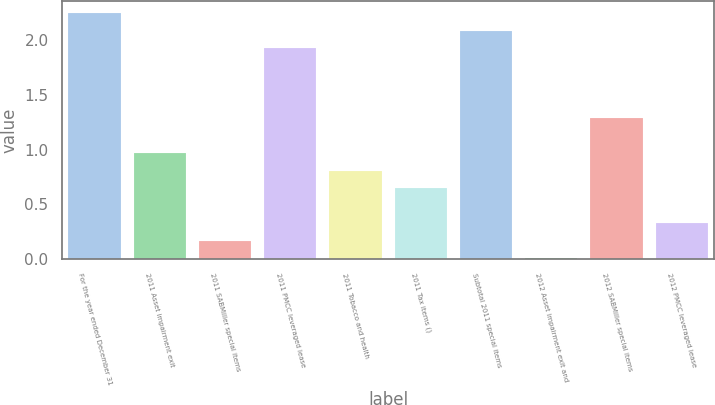<chart> <loc_0><loc_0><loc_500><loc_500><bar_chart><fcel>For the year ended December 31<fcel>2011 Asset impairment exit<fcel>2011 SABMiller special items<fcel>2011 PMCC leveraged lease<fcel>2011 Tobacco and health<fcel>2011 Tax items ()<fcel>Subtotal 2011 special items<fcel>2012 Asset impairment exit and<fcel>2012 SABMiller special items<fcel>2012 PMCC leveraged lease<nl><fcel>2.25<fcel>0.97<fcel>0.17<fcel>1.93<fcel>0.81<fcel>0.65<fcel>2.09<fcel>0.01<fcel>1.29<fcel>0.33<nl></chart> 